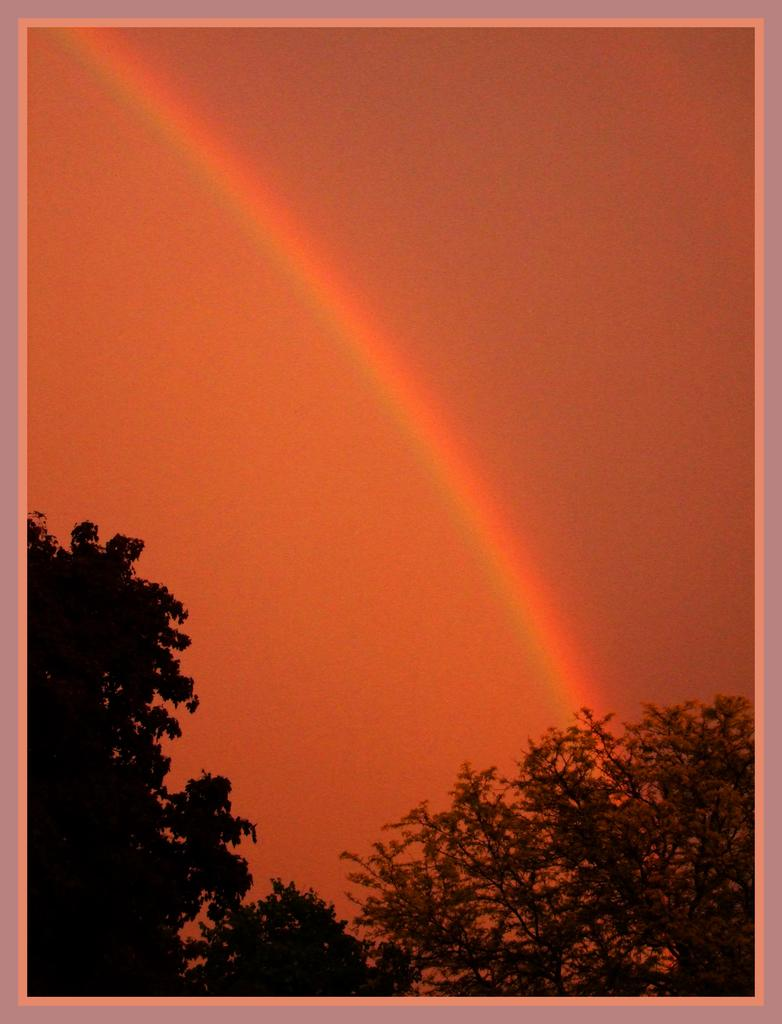What is the main object in the image? There is a frame in the image. What can be seen in the background of the image? The sky is visible in the image. What natural phenomenon is present in the image? There is a rainbow in the image. What type of vegetation is present in the image? Trees are present in the image. Can you tell me how many beggars are visible in the image? There are no beggars present in the image. What type of gun is being used by the person in the image? There is no person or gun present in the image. 